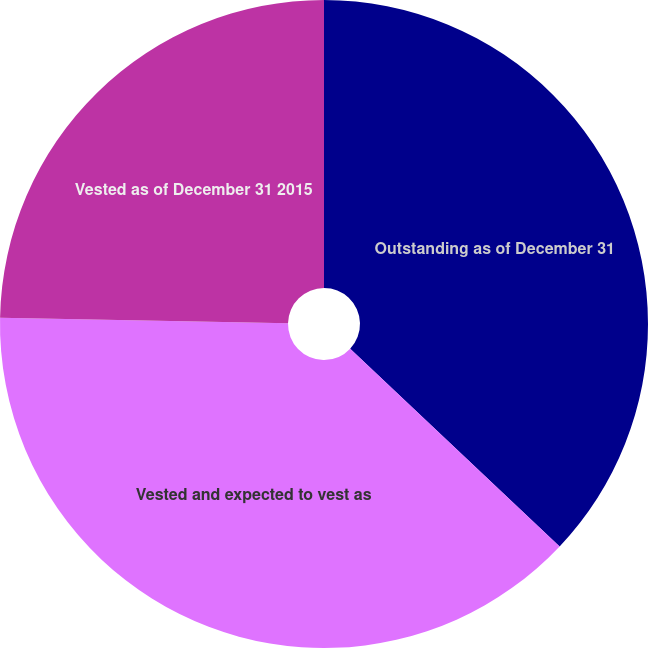Convert chart to OTSL. <chart><loc_0><loc_0><loc_500><loc_500><pie_chart><fcel>Outstanding as of December 31<fcel>Vested and expected to vest as<fcel>Vested as of December 31 2015<nl><fcel>37.04%<fcel>38.27%<fcel>24.69%<nl></chart> 